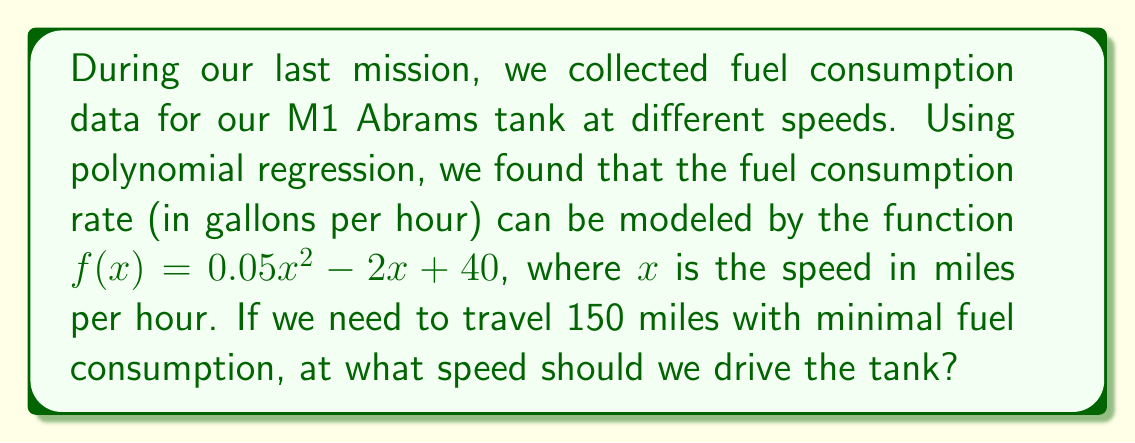Give your solution to this math problem. Let's approach this step-by-step:

1) First, we need to find the total fuel consumption for the 150-mile journey. This can be expressed as:

   $\text{Total Fuel} = \frac{150 \text{ miles}}{x \text{ miles/hour}} \cdot f(x) \text{ gallons/hour}$

2) Simplify this expression:

   $\text{Total Fuel} = \frac{150}{x} \cdot (0.05x^2 - 2x + 40)$
   
   $\text{Total Fuel} = 150 \cdot (0.05x - 2 + \frac{40}{x})$

3) To find the minimum fuel consumption, we need to find the minimum of this function. We can do this by differentiating with respect to $x$ and setting it equal to zero:

   $\frac{d}{dx}(\text{Total Fuel}) = 150 \cdot (0.05 - \frac{40}{x^2}) = 0$

4) Solve this equation:

   $0.05 - \frac{40}{x^2} = 0$
   
   $0.05x^2 = 40$
   
   $x^2 = 800$
   
   $x = \sqrt{800} \approx 28.28$

5) To confirm this is a minimum, we could check the second derivative is positive, but given the context, this must be a minimum.

Therefore, to minimize fuel consumption, we should drive the tank at approximately 28.28 miles per hour.
Answer: $28.28$ mph 